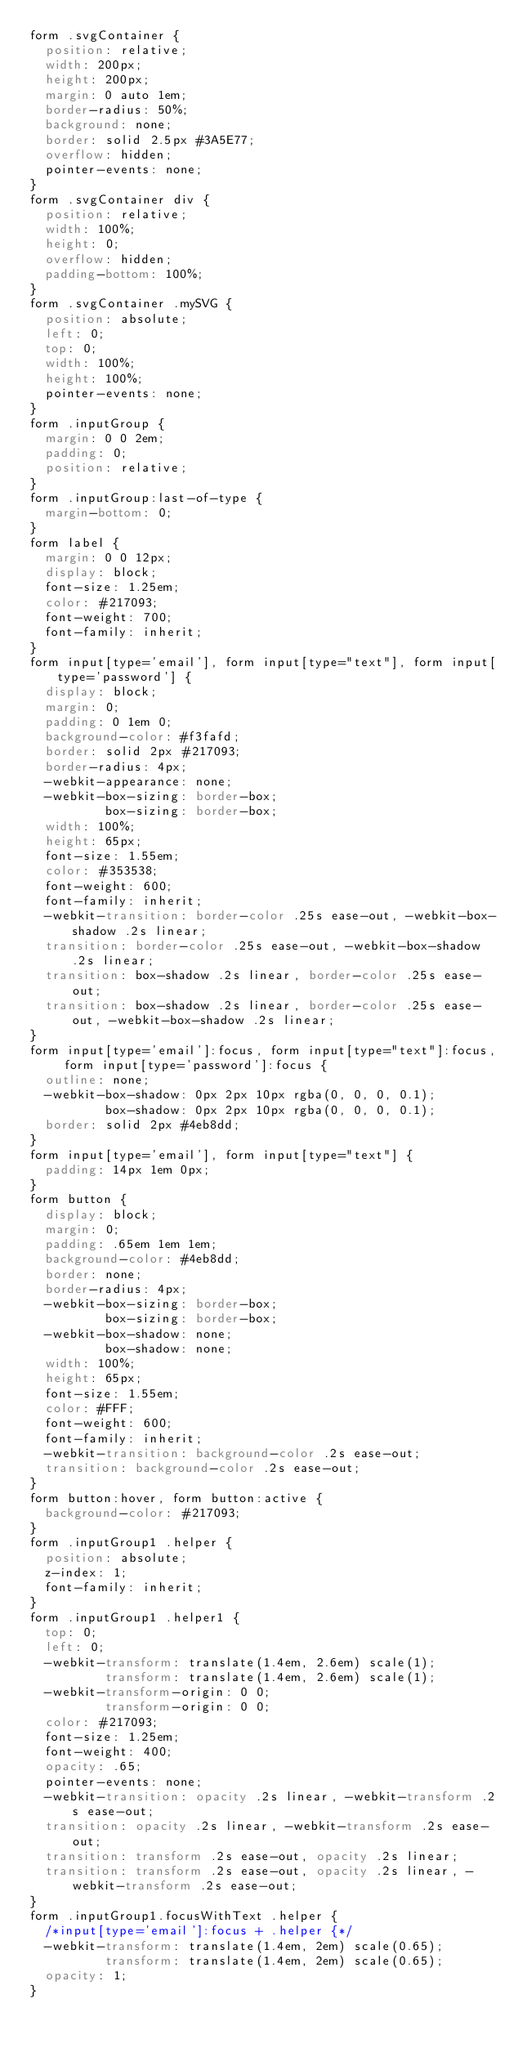<code> <loc_0><loc_0><loc_500><loc_500><_CSS_>form .svgContainer {
  position: relative;
  width: 200px;
  height: 200px;
  margin: 0 auto 1em;
  border-radius: 50%;
  background: none;
  border: solid 2.5px #3A5E77;
  overflow: hidden;
  pointer-events: none;
}
form .svgContainer div {
  position: relative;
  width: 100%;
  height: 0;
  overflow: hidden;
  padding-bottom: 100%;
}
form .svgContainer .mySVG {
  position: absolute;
  left: 0;
  top: 0;
  width: 100%;
  height: 100%;
  pointer-events: none;
}
form .inputGroup {
  margin: 0 0 2em;
  padding: 0;
  position: relative;
}
form .inputGroup:last-of-type {
  margin-bottom: 0;
}
form label {
  margin: 0 0 12px;
  display: block;
  font-size: 1.25em;
  color: #217093;
  font-weight: 700;
  font-family: inherit;
}
form input[type='email'], form input[type="text"], form input[type='password'] {
  display: block;
  margin: 0;
  padding: 0 1em 0;
  background-color: #f3fafd;
  border: solid 2px #217093;
  border-radius: 4px;
  -webkit-appearance: none;
  -webkit-box-sizing: border-box;
          box-sizing: border-box;
  width: 100%;
  height: 65px;
  font-size: 1.55em;
  color: #353538;
  font-weight: 600;
  font-family: inherit;
  -webkit-transition: border-color .25s ease-out, -webkit-box-shadow .2s linear;
  transition: border-color .25s ease-out, -webkit-box-shadow .2s linear;
  transition: box-shadow .2s linear, border-color .25s ease-out;
  transition: box-shadow .2s linear, border-color .25s ease-out, -webkit-box-shadow .2s linear;
}
form input[type='email']:focus, form input[type="text"]:focus, form input[type='password']:focus {
  outline: none;
  -webkit-box-shadow: 0px 2px 10px rgba(0, 0, 0, 0.1);
          box-shadow: 0px 2px 10px rgba(0, 0, 0, 0.1);
  border: solid 2px #4eb8dd;
}
form input[type='email'], form input[type="text"] {
  padding: 14px 1em 0px;
}
form button {
  display: block;
  margin: 0;
  padding: .65em 1em 1em;
  background-color: #4eb8dd;
  border: none;
  border-radius: 4px;
  -webkit-box-sizing: border-box;
          box-sizing: border-box;
  -webkit-box-shadow: none;
          box-shadow: none;
  width: 100%;
  height: 65px;
  font-size: 1.55em;
  color: #FFF;
  font-weight: 600;
  font-family: inherit;
  -webkit-transition: background-color .2s ease-out;
  transition: background-color .2s ease-out;
}
form button:hover, form button:active {
  background-color: #217093;
}
form .inputGroup1 .helper {
  position: absolute;
  z-index: 1;
  font-family: inherit;
}
form .inputGroup1 .helper1 {
  top: 0;
  left: 0;
  -webkit-transform: translate(1.4em, 2.6em) scale(1);
          transform: translate(1.4em, 2.6em) scale(1);
  -webkit-transform-origin: 0 0;
          transform-origin: 0 0;
  color: #217093;
  font-size: 1.25em;
  font-weight: 400;
  opacity: .65;
  pointer-events: none;
  -webkit-transition: opacity .2s linear, -webkit-transform .2s ease-out;
  transition: opacity .2s linear, -webkit-transform .2s ease-out;
  transition: transform .2s ease-out, opacity .2s linear;
  transition: transform .2s ease-out, opacity .2s linear, -webkit-transform .2s ease-out;
}
form .inputGroup1.focusWithText .helper {
  /*input[type='email']:focus + .helper {*/
  -webkit-transform: translate(1.4em, 2em) scale(0.65);
          transform: translate(1.4em, 2em) scale(0.65);
  opacity: 1;
}
</code> 